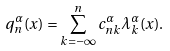<formula> <loc_0><loc_0><loc_500><loc_500>q _ { n } ^ { \alpha } ( x ) = \sum _ { k = - \infty } ^ { n } c _ { n k } ^ { \alpha } \lambda _ { k } ^ { \alpha } ( x ) .</formula> 